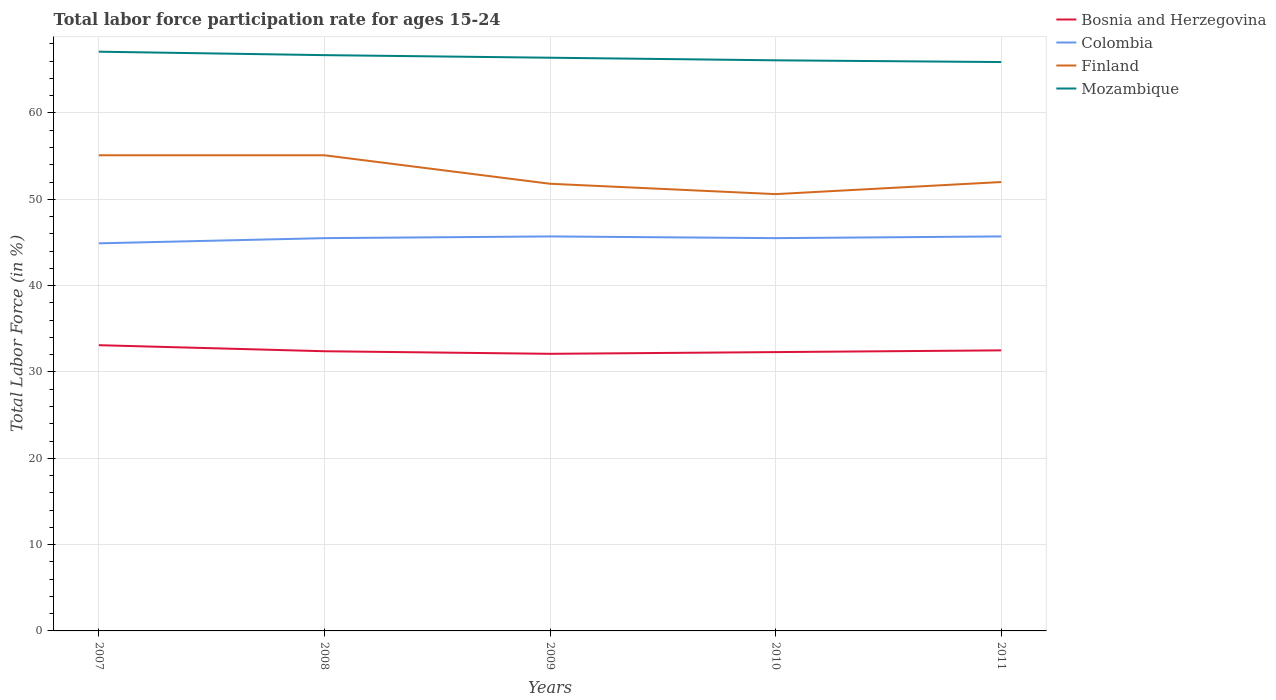How many different coloured lines are there?
Provide a short and direct response. 4. Does the line corresponding to Mozambique intersect with the line corresponding to Finland?
Keep it short and to the point. No. Across all years, what is the maximum labor force participation rate in Bosnia and Herzegovina?
Offer a very short reply. 32.1. What is the total labor force participation rate in Mozambique in the graph?
Offer a terse response. 0.6. What is the difference between the highest and the second highest labor force participation rate in Colombia?
Provide a succinct answer. 0.8. What is the difference between the highest and the lowest labor force participation rate in Colombia?
Offer a very short reply. 4. Is the labor force participation rate in Mozambique strictly greater than the labor force participation rate in Finland over the years?
Provide a succinct answer. No. What is the difference between two consecutive major ticks on the Y-axis?
Ensure brevity in your answer.  10. Are the values on the major ticks of Y-axis written in scientific E-notation?
Offer a very short reply. No. Does the graph contain grids?
Offer a terse response. Yes. Where does the legend appear in the graph?
Make the answer very short. Top right. How many legend labels are there?
Offer a very short reply. 4. How are the legend labels stacked?
Your answer should be very brief. Vertical. What is the title of the graph?
Give a very brief answer. Total labor force participation rate for ages 15-24. What is the label or title of the X-axis?
Offer a terse response. Years. What is the Total Labor Force (in %) of Bosnia and Herzegovina in 2007?
Offer a terse response. 33.1. What is the Total Labor Force (in %) in Colombia in 2007?
Your answer should be very brief. 44.9. What is the Total Labor Force (in %) of Finland in 2007?
Your answer should be very brief. 55.1. What is the Total Labor Force (in %) in Mozambique in 2007?
Give a very brief answer. 67.1. What is the Total Labor Force (in %) in Bosnia and Herzegovina in 2008?
Provide a short and direct response. 32.4. What is the Total Labor Force (in %) of Colombia in 2008?
Your answer should be very brief. 45.5. What is the Total Labor Force (in %) of Finland in 2008?
Your answer should be very brief. 55.1. What is the Total Labor Force (in %) in Mozambique in 2008?
Your answer should be compact. 66.7. What is the Total Labor Force (in %) in Bosnia and Herzegovina in 2009?
Your answer should be very brief. 32.1. What is the Total Labor Force (in %) in Colombia in 2009?
Make the answer very short. 45.7. What is the Total Labor Force (in %) of Finland in 2009?
Offer a terse response. 51.8. What is the Total Labor Force (in %) of Mozambique in 2009?
Ensure brevity in your answer.  66.4. What is the Total Labor Force (in %) of Bosnia and Herzegovina in 2010?
Give a very brief answer. 32.3. What is the Total Labor Force (in %) of Colombia in 2010?
Your answer should be very brief. 45.5. What is the Total Labor Force (in %) in Finland in 2010?
Your answer should be compact. 50.6. What is the Total Labor Force (in %) of Mozambique in 2010?
Your answer should be very brief. 66.1. What is the Total Labor Force (in %) of Bosnia and Herzegovina in 2011?
Offer a very short reply. 32.5. What is the Total Labor Force (in %) in Colombia in 2011?
Your answer should be compact. 45.7. What is the Total Labor Force (in %) of Mozambique in 2011?
Your response must be concise. 65.9. Across all years, what is the maximum Total Labor Force (in %) in Bosnia and Herzegovina?
Your answer should be compact. 33.1. Across all years, what is the maximum Total Labor Force (in %) in Colombia?
Provide a short and direct response. 45.7. Across all years, what is the maximum Total Labor Force (in %) of Finland?
Make the answer very short. 55.1. Across all years, what is the maximum Total Labor Force (in %) in Mozambique?
Ensure brevity in your answer.  67.1. Across all years, what is the minimum Total Labor Force (in %) of Bosnia and Herzegovina?
Your response must be concise. 32.1. Across all years, what is the minimum Total Labor Force (in %) in Colombia?
Ensure brevity in your answer.  44.9. Across all years, what is the minimum Total Labor Force (in %) of Finland?
Keep it short and to the point. 50.6. Across all years, what is the minimum Total Labor Force (in %) in Mozambique?
Your answer should be compact. 65.9. What is the total Total Labor Force (in %) of Bosnia and Herzegovina in the graph?
Your answer should be compact. 162.4. What is the total Total Labor Force (in %) in Colombia in the graph?
Your answer should be very brief. 227.3. What is the total Total Labor Force (in %) of Finland in the graph?
Ensure brevity in your answer.  264.6. What is the total Total Labor Force (in %) of Mozambique in the graph?
Offer a terse response. 332.2. What is the difference between the Total Labor Force (in %) in Finland in 2007 and that in 2008?
Your response must be concise. 0. What is the difference between the Total Labor Force (in %) in Bosnia and Herzegovina in 2007 and that in 2009?
Your response must be concise. 1. What is the difference between the Total Labor Force (in %) of Finland in 2007 and that in 2009?
Your answer should be very brief. 3.3. What is the difference between the Total Labor Force (in %) in Mozambique in 2007 and that in 2009?
Offer a very short reply. 0.7. What is the difference between the Total Labor Force (in %) in Bosnia and Herzegovina in 2007 and that in 2010?
Offer a very short reply. 0.8. What is the difference between the Total Labor Force (in %) of Finland in 2007 and that in 2011?
Offer a terse response. 3.1. What is the difference between the Total Labor Force (in %) of Bosnia and Herzegovina in 2008 and that in 2009?
Your answer should be compact. 0.3. What is the difference between the Total Labor Force (in %) of Colombia in 2008 and that in 2009?
Your response must be concise. -0.2. What is the difference between the Total Labor Force (in %) of Mozambique in 2008 and that in 2009?
Your response must be concise. 0.3. What is the difference between the Total Labor Force (in %) in Bosnia and Herzegovina in 2008 and that in 2010?
Provide a succinct answer. 0.1. What is the difference between the Total Labor Force (in %) of Finland in 2008 and that in 2011?
Offer a very short reply. 3.1. What is the difference between the Total Labor Force (in %) in Mozambique in 2008 and that in 2011?
Your answer should be very brief. 0.8. What is the difference between the Total Labor Force (in %) in Colombia in 2009 and that in 2010?
Ensure brevity in your answer.  0.2. What is the difference between the Total Labor Force (in %) in Finland in 2009 and that in 2010?
Provide a short and direct response. 1.2. What is the difference between the Total Labor Force (in %) in Colombia in 2009 and that in 2011?
Offer a terse response. 0. What is the difference between the Total Labor Force (in %) of Bosnia and Herzegovina in 2010 and that in 2011?
Give a very brief answer. -0.2. What is the difference between the Total Labor Force (in %) in Finland in 2010 and that in 2011?
Keep it short and to the point. -1.4. What is the difference between the Total Labor Force (in %) of Bosnia and Herzegovina in 2007 and the Total Labor Force (in %) of Colombia in 2008?
Provide a short and direct response. -12.4. What is the difference between the Total Labor Force (in %) of Bosnia and Herzegovina in 2007 and the Total Labor Force (in %) of Finland in 2008?
Your response must be concise. -22. What is the difference between the Total Labor Force (in %) in Bosnia and Herzegovina in 2007 and the Total Labor Force (in %) in Mozambique in 2008?
Your answer should be compact. -33.6. What is the difference between the Total Labor Force (in %) of Colombia in 2007 and the Total Labor Force (in %) of Mozambique in 2008?
Give a very brief answer. -21.8. What is the difference between the Total Labor Force (in %) of Finland in 2007 and the Total Labor Force (in %) of Mozambique in 2008?
Give a very brief answer. -11.6. What is the difference between the Total Labor Force (in %) in Bosnia and Herzegovina in 2007 and the Total Labor Force (in %) in Colombia in 2009?
Your answer should be compact. -12.6. What is the difference between the Total Labor Force (in %) of Bosnia and Herzegovina in 2007 and the Total Labor Force (in %) of Finland in 2009?
Provide a succinct answer. -18.7. What is the difference between the Total Labor Force (in %) in Bosnia and Herzegovina in 2007 and the Total Labor Force (in %) in Mozambique in 2009?
Provide a short and direct response. -33.3. What is the difference between the Total Labor Force (in %) of Colombia in 2007 and the Total Labor Force (in %) of Finland in 2009?
Provide a short and direct response. -6.9. What is the difference between the Total Labor Force (in %) of Colombia in 2007 and the Total Labor Force (in %) of Mozambique in 2009?
Keep it short and to the point. -21.5. What is the difference between the Total Labor Force (in %) of Bosnia and Herzegovina in 2007 and the Total Labor Force (in %) of Finland in 2010?
Your response must be concise. -17.5. What is the difference between the Total Labor Force (in %) in Bosnia and Herzegovina in 2007 and the Total Labor Force (in %) in Mozambique in 2010?
Give a very brief answer. -33. What is the difference between the Total Labor Force (in %) in Colombia in 2007 and the Total Labor Force (in %) in Mozambique in 2010?
Keep it short and to the point. -21.2. What is the difference between the Total Labor Force (in %) in Finland in 2007 and the Total Labor Force (in %) in Mozambique in 2010?
Your response must be concise. -11. What is the difference between the Total Labor Force (in %) of Bosnia and Herzegovina in 2007 and the Total Labor Force (in %) of Finland in 2011?
Offer a terse response. -18.9. What is the difference between the Total Labor Force (in %) in Bosnia and Herzegovina in 2007 and the Total Labor Force (in %) in Mozambique in 2011?
Give a very brief answer. -32.8. What is the difference between the Total Labor Force (in %) of Bosnia and Herzegovina in 2008 and the Total Labor Force (in %) of Finland in 2009?
Keep it short and to the point. -19.4. What is the difference between the Total Labor Force (in %) of Bosnia and Herzegovina in 2008 and the Total Labor Force (in %) of Mozambique in 2009?
Your answer should be compact. -34. What is the difference between the Total Labor Force (in %) in Colombia in 2008 and the Total Labor Force (in %) in Mozambique in 2009?
Your response must be concise. -20.9. What is the difference between the Total Labor Force (in %) in Finland in 2008 and the Total Labor Force (in %) in Mozambique in 2009?
Provide a succinct answer. -11.3. What is the difference between the Total Labor Force (in %) of Bosnia and Herzegovina in 2008 and the Total Labor Force (in %) of Finland in 2010?
Give a very brief answer. -18.2. What is the difference between the Total Labor Force (in %) in Bosnia and Herzegovina in 2008 and the Total Labor Force (in %) in Mozambique in 2010?
Give a very brief answer. -33.7. What is the difference between the Total Labor Force (in %) of Colombia in 2008 and the Total Labor Force (in %) of Finland in 2010?
Keep it short and to the point. -5.1. What is the difference between the Total Labor Force (in %) of Colombia in 2008 and the Total Labor Force (in %) of Mozambique in 2010?
Offer a very short reply. -20.6. What is the difference between the Total Labor Force (in %) in Bosnia and Herzegovina in 2008 and the Total Labor Force (in %) in Finland in 2011?
Give a very brief answer. -19.6. What is the difference between the Total Labor Force (in %) in Bosnia and Herzegovina in 2008 and the Total Labor Force (in %) in Mozambique in 2011?
Keep it short and to the point. -33.5. What is the difference between the Total Labor Force (in %) of Colombia in 2008 and the Total Labor Force (in %) of Finland in 2011?
Make the answer very short. -6.5. What is the difference between the Total Labor Force (in %) of Colombia in 2008 and the Total Labor Force (in %) of Mozambique in 2011?
Offer a terse response. -20.4. What is the difference between the Total Labor Force (in %) in Bosnia and Herzegovina in 2009 and the Total Labor Force (in %) in Colombia in 2010?
Provide a succinct answer. -13.4. What is the difference between the Total Labor Force (in %) in Bosnia and Herzegovina in 2009 and the Total Labor Force (in %) in Finland in 2010?
Give a very brief answer. -18.5. What is the difference between the Total Labor Force (in %) in Bosnia and Herzegovina in 2009 and the Total Labor Force (in %) in Mozambique in 2010?
Offer a very short reply. -34. What is the difference between the Total Labor Force (in %) of Colombia in 2009 and the Total Labor Force (in %) of Finland in 2010?
Your answer should be compact. -4.9. What is the difference between the Total Labor Force (in %) of Colombia in 2009 and the Total Labor Force (in %) of Mozambique in 2010?
Offer a terse response. -20.4. What is the difference between the Total Labor Force (in %) of Finland in 2009 and the Total Labor Force (in %) of Mozambique in 2010?
Give a very brief answer. -14.3. What is the difference between the Total Labor Force (in %) of Bosnia and Herzegovina in 2009 and the Total Labor Force (in %) of Finland in 2011?
Provide a short and direct response. -19.9. What is the difference between the Total Labor Force (in %) of Bosnia and Herzegovina in 2009 and the Total Labor Force (in %) of Mozambique in 2011?
Provide a succinct answer. -33.8. What is the difference between the Total Labor Force (in %) in Colombia in 2009 and the Total Labor Force (in %) in Mozambique in 2011?
Make the answer very short. -20.2. What is the difference between the Total Labor Force (in %) in Finland in 2009 and the Total Labor Force (in %) in Mozambique in 2011?
Provide a succinct answer. -14.1. What is the difference between the Total Labor Force (in %) of Bosnia and Herzegovina in 2010 and the Total Labor Force (in %) of Colombia in 2011?
Make the answer very short. -13.4. What is the difference between the Total Labor Force (in %) of Bosnia and Herzegovina in 2010 and the Total Labor Force (in %) of Finland in 2011?
Provide a succinct answer. -19.7. What is the difference between the Total Labor Force (in %) in Bosnia and Herzegovina in 2010 and the Total Labor Force (in %) in Mozambique in 2011?
Ensure brevity in your answer.  -33.6. What is the difference between the Total Labor Force (in %) in Colombia in 2010 and the Total Labor Force (in %) in Finland in 2011?
Provide a short and direct response. -6.5. What is the difference between the Total Labor Force (in %) in Colombia in 2010 and the Total Labor Force (in %) in Mozambique in 2011?
Your response must be concise. -20.4. What is the difference between the Total Labor Force (in %) in Finland in 2010 and the Total Labor Force (in %) in Mozambique in 2011?
Give a very brief answer. -15.3. What is the average Total Labor Force (in %) in Bosnia and Herzegovina per year?
Offer a terse response. 32.48. What is the average Total Labor Force (in %) of Colombia per year?
Your answer should be very brief. 45.46. What is the average Total Labor Force (in %) in Finland per year?
Ensure brevity in your answer.  52.92. What is the average Total Labor Force (in %) of Mozambique per year?
Ensure brevity in your answer.  66.44. In the year 2007, what is the difference between the Total Labor Force (in %) in Bosnia and Herzegovina and Total Labor Force (in %) in Mozambique?
Give a very brief answer. -34. In the year 2007, what is the difference between the Total Labor Force (in %) of Colombia and Total Labor Force (in %) of Finland?
Make the answer very short. -10.2. In the year 2007, what is the difference between the Total Labor Force (in %) of Colombia and Total Labor Force (in %) of Mozambique?
Your answer should be compact. -22.2. In the year 2008, what is the difference between the Total Labor Force (in %) in Bosnia and Herzegovina and Total Labor Force (in %) in Finland?
Your answer should be compact. -22.7. In the year 2008, what is the difference between the Total Labor Force (in %) in Bosnia and Herzegovina and Total Labor Force (in %) in Mozambique?
Provide a succinct answer. -34.3. In the year 2008, what is the difference between the Total Labor Force (in %) in Colombia and Total Labor Force (in %) in Finland?
Your answer should be very brief. -9.6. In the year 2008, what is the difference between the Total Labor Force (in %) of Colombia and Total Labor Force (in %) of Mozambique?
Your answer should be compact. -21.2. In the year 2008, what is the difference between the Total Labor Force (in %) of Finland and Total Labor Force (in %) of Mozambique?
Provide a short and direct response. -11.6. In the year 2009, what is the difference between the Total Labor Force (in %) in Bosnia and Herzegovina and Total Labor Force (in %) in Colombia?
Make the answer very short. -13.6. In the year 2009, what is the difference between the Total Labor Force (in %) of Bosnia and Herzegovina and Total Labor Force (in %) of Finland?
Make the answer very short. -19.7. In the year 2009, what is the difference between the Total Labor Force (in %) in Bosnia and Herzegovina and Total Labor Force (in %) in Mozambique?
Provide a succinct answer. -34.3. In the year 2009, what is the difference between the Total Labor Force (in %) in Colombia and Total Labor Force (in %) in Mozambique?
Ensure brevity in your answer.  -20.7. In the year 2009, what is the difference between the Total Labor Force (in %) of Finland and Total Labor Force (in %) of Mozambique?
Provide a short and direct response. -14.6. In the year 2010, what is the difference between the Total Labor Force (in %) in Bosnia and Herzegovina and Total Labor Force (in %) in Finland?
Your answer should be very brief. -18.3. In the year 2010, what is the difference between the Total Labor Force (in %) in Bosnia and Herzegovina and Total Labor Force (in %) in Mozambique?
Your response must be concise. -33.8. In the year 2010, what is the difference between the Total Labor Force (in %) in Colombia and Total Labor Force (in %) in Mozambique?
Your answer should be very brief. -20.6. In the year 2010, what is the difference between the Total Labor Force (in %) in Finland and Total Labor Force (in %) in Mozambique?
Make the answer very short. -15.5. In the year 2011, what is the difference between the Total Labor Force (in %) in Bosnia and Herzegovina and Total Labor Force (in %) in Finland?
Your answer should be very brief. -19.5. In the year 2011, what is the difference between the Total Labor Force (in %) of Bosnia and Herzegovina and Total Labor Force (in %) of Mozambique?
Ensure brevity in your answer.  -33.4. In the year 2011, what is the difference between the Total Labor Force (in %) of Colombia and Total Labor Force (in %) of Finland?
Your answer should be very brief. -6.3. In the year 2011, what is the difference between the Total Labor Force (in %) of Colombia and Total Labor Force (in %) of Mozambique?
Provide a short and direct response. -20.2. In the year 2011, what is the difference between the Total Labor Force (in %) of Finland and Total Labor Force (in %) of Mozambique?
Ensure brevity in your answer.  -13.9. What is the ratio of the Total Labor Force (in %) of Bosnia and Herzegovina in 2007 to that in 2008?
Ensure brevity in your answer.  1.02. What is the ratio of the Total Labor Force (in %) of Colombia in 2007 to that in 2008?
Make the answer very short. 0.99. What is the ratio of the Total Labor Force (in %) in Finland in 2007 to that in 2008?
Your answer should be compact. 1. What is the ratio of the Total Labor Force (in %) of Bosnia and Herzegovina in 2007 to that in 2009?
Offer a terse response. 1.03. What is the ratio of the Total Labor Force (in %) of Colombia in 2007 to that in 2009?
Offer a very short reply. 0.98. What is the ratio of the Total Labor Force (in %) of Finland in 2007 to that in 2009?
Your response must be concise. 1.06. What is the ratio of the Total Labor Force (in %) in Mozambique in 2007 to that in 2009?
Your response must be concise. 1.01. What is the ratio of the Total Labor Force (in %) in Bosnia and Herzegovina in 2007 to that in 2010?
Your response must be concise. 1.02. What is the ratio of the Total Labor Force (in %) in Colombia in 2007 to that in 2010?
Keep it short and to the point. 0.99. What is the ratio of the Total Labor Force (in %) of Finland in 2007 to that in 2010?
Ensure brevity in your answer.  1.09. What is the ratio of the Total Labor Force (in %) in Mozambique in 2007 to that in 2010?
Offer a terse response. 1.02. What is the ratio of the Total Labor Force (in %) of Bosnia and Herzegovina in 2007 to that in 2011?
Keep it short and to the point. 1.02. What is the ratio of the Total Labor Force (in %) in Colombia in 2007 to that in 2011?
Provide a succinct answer. 0.98. What is the ratio of the Total Labor Force (in %) of Finland in 2007 to that in 2011?
Give a very brief answer. 1.06. What is the ratio of the Total Labor Force (in %) in Mozambique in 2007 to that in 2011?
Keep it short and to the point. 1.02. What is the ratio of the Total Labor Force (in %) of Bosnia and Herzegovina in 2008 to that in 2009?
Give a very brief answer. 1.01. What is the ratio of the Total Labor Force (in %) in Finland in 2008 to that in 2009?
Provide a succinct answer. 1.06. What is the ratio of the Total Labor Force (in %) of Mozambique in 2008 to that in 2009?
Offer a terse response. 1. What is the ratio of the Total Labor Force (in %) in Finland in 2008 to that in 2010?
Provide a short and direct response. 1.09. What is the ratio of the Total Labor Force (in %) of Mozambique in 2008 to that in 2010?
Provide a short and direct response. 1.01. What is the ratio of the Total Labor Force (in %) of Bosnia and Herzegovina in 2008 to that in 2011?
Ensure brevity in your answer.  1. What is the ratio of the Total Labor Force (in %) of Finland in 2008 to that in 2011?
Your answer should be compact. 1.06. What is the ratio of the Total Labor Force (in %) of Mozambique in 2008 to that in 2011?
Keep it short and to the point. 1.01. What is the ratio of the Total Labor Force (in %) of Finland in 2009 to that in 2010?
Give a very brief answer. 1.02. What is the ratio of the Total Labor Force (in %) of Bosnia and Herzegovina in 2009 to that in 2011?
Your answer should be very brief. 0.99. What is the ratio of the Total Labor Force (in %) in Finland in 2009 to that in 2011?
Provide a short and direct response. 1. What is the ratio of the Total Labor Force (in %) of Mozambique in 2009 to that in 2011?
Provide a succinct answer. 1.01. What is the ratio of the Total Labor Force (in %) in Bosnia and Herzegovina in 2010 to that in 2011?
Your answer should be very brief. 0.99. What is the ratio of the Total Labor Force (in %) in Finland in 2010 to that in 2011?
Offer a terse response. 0.97. What is the difference between the highest and the second highest Total Labor Force (in %) of Bosnia and Herzegovina?
Offer a terse response. 0.6. What is the difference between the highest and the second highest Total Labor Force (in %) in Finland?
Keep it short and to the point. 0. What is the difference between the highest and the second highest Total Labor Force (in %) in Mozambique?
Your answer should be compact. 0.4. What is the difference between the highest and the lowest Total Labor Force (in %) in Bosnia and Herzegovina?
Your response must be concise. 1. 